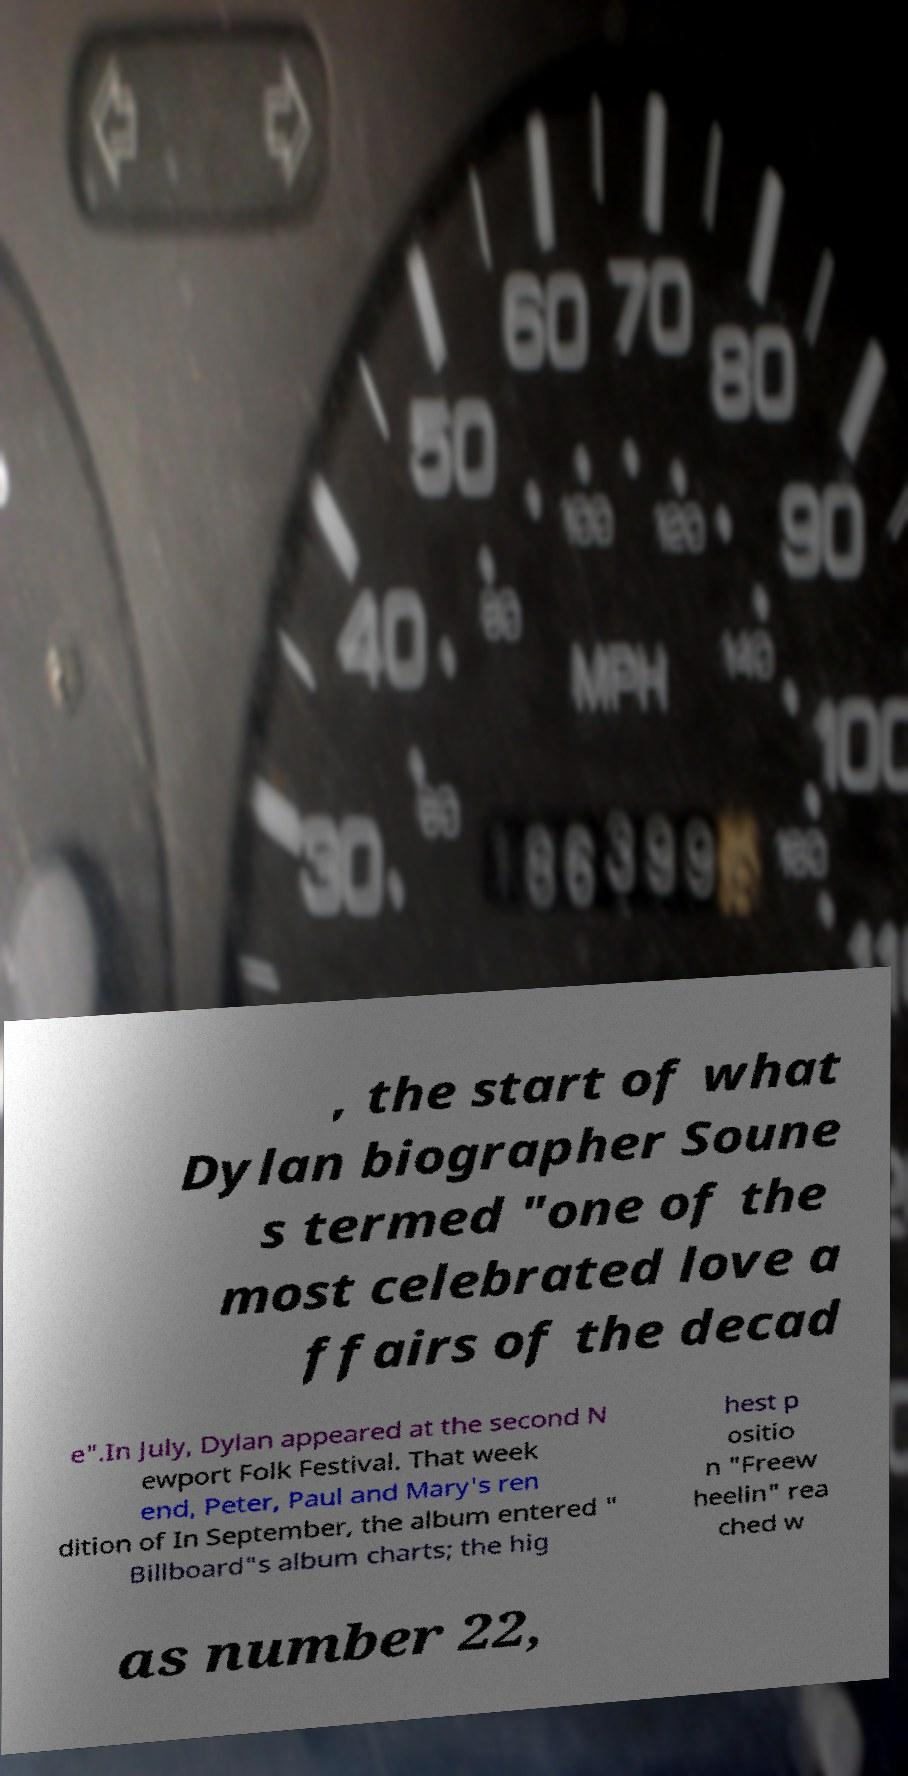Please identify and transcribe the text found in this image. , the start of what Dylan biographer Soune s termed "one of the most celebrated love a ffairs of the decad e".In July, Dylan appeared at the second N ewport Folk Festival. That week end, Peter, Paul and Mary's ren dition of In September, the album entered " Billboard"s album charts; the hig hest p ositio n "Freew heelin" rea ched w as number 22, 